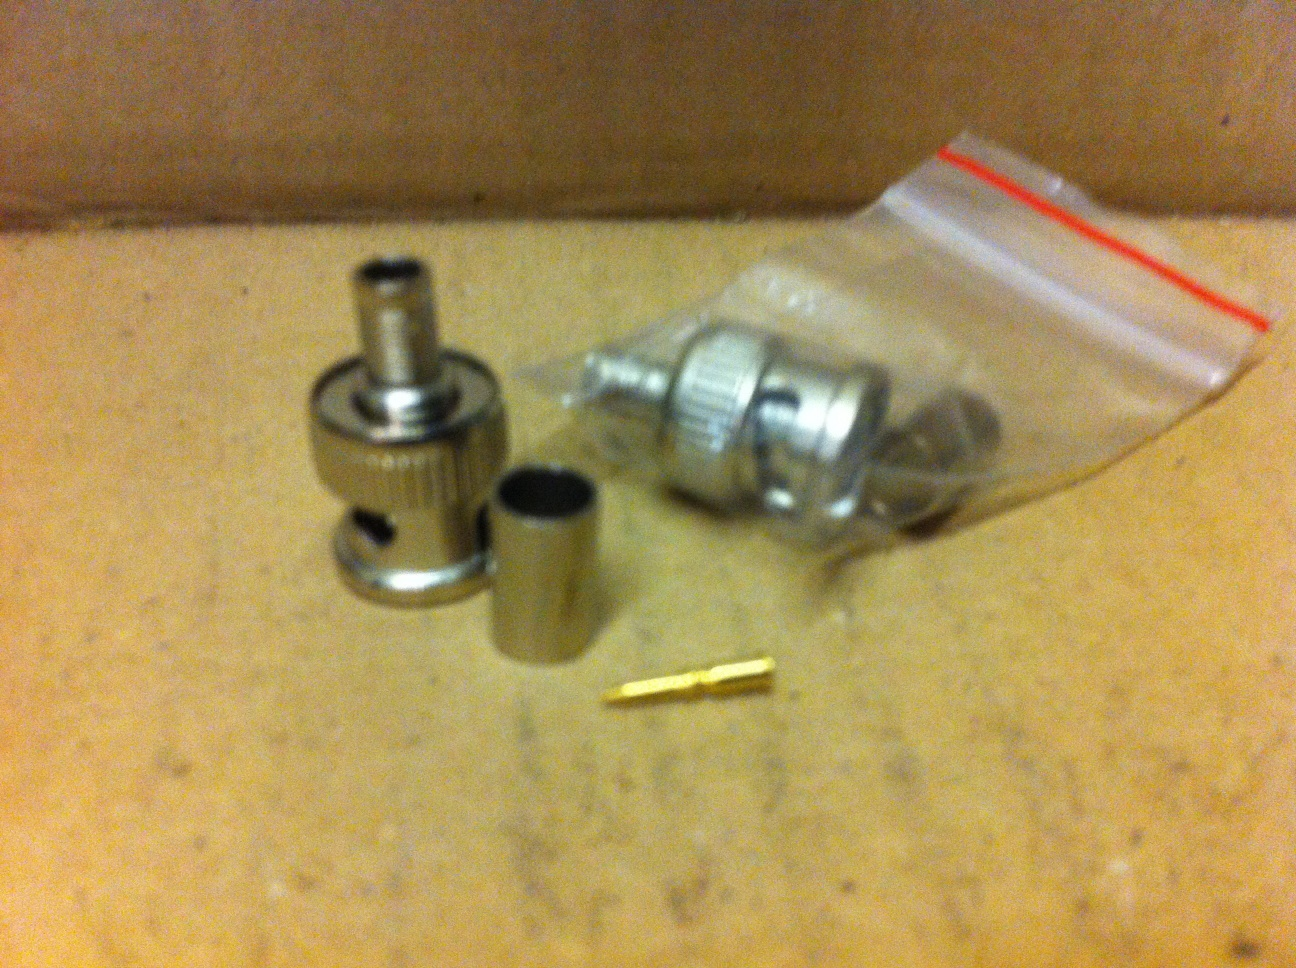Describe a short realistic scenario where these parts are useful An amateur radio operator needs to replace a damaged connector on their coaxial cable to maintain good signal quality. They use these parts to attach a new end to their cable, ensuring they can again communicate clearly with their fellow radio enthusiasts. 